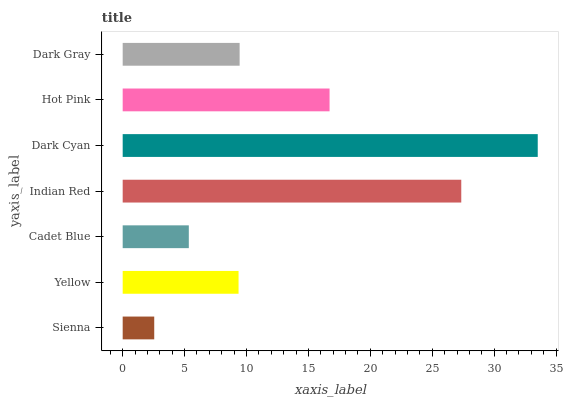Is Sienna the minimum?
Answer yes or no. Yes. Is Dark Cyan the maximum?
Answer yes or no. Yes. Is Yellow the minimum?
Answer yes or no. No. Is Yellow the maximum?
Answer yes or no. No. Is Yellow greater than Sienna?
Answer yes or no. Yes. Is Sienna less than Yellow?
Answer yes or no. Yes. Is Sienna greater than Yellow?
Answer yes or no. No. Is Yellow less than Sienna?
Answer yes or no. No. Is Dark Gray the high median?
Answer yes or no. Yes. Is Dark Gray the low median?
Answer yes or no. Yes. Is Sienna the high median?
Answer yes or no. No. Is Cadet Blue the low median?
Answer yes or no. No. 